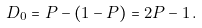<formula> <loc_0><loc_0><loc_500><loc_500>D _ { 0 } = P - ( 1 - P ) = 2 P - 1 \, .</formula> 